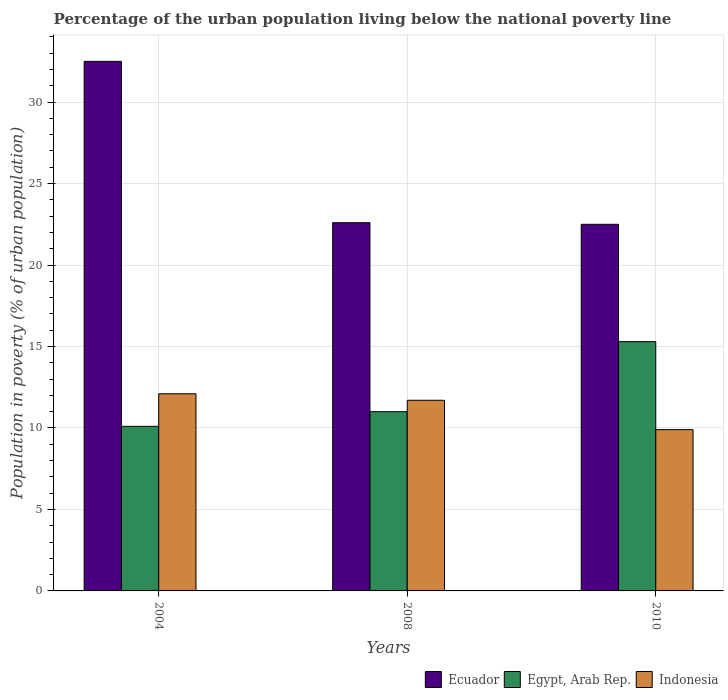Are the number of bars per tick equal to the number of legend labels?
Make the answer very short. Yes. How many bars are there on the 1st tick from the left?
Make the answer very short. 3. What is the label of the 2nd group of bars from the left?
Your response must be concise. 2008. In how many cases, is the number of bars for a given year not equal to the number of legend labels?
Make the answer very short. 0. What is the percentage of the urban population living below the national poverty line in Indonesia in 2010?
Offer a very short reply. 9.9. In which year was the percentage of the urban population living below the national poverty line in Indonesia maximum?
Offer a very short reply. 2004. What is the total percentage of the urban population living below the national poverty line in Ecuador in the graph?
Offer a terse response. 77.6. What is the difference between the percentage of the urban population living below the national poverty line in Indonesia in 2004 and that in 2010?
Provide a short and direct response. 2.2. What is the average percentage of the urban population living below the national poverty line in Indonesia per year?
Offer a terse response. 11.23. In the year 2004, what is the difference between the percentage of the urban population living below the national poverty line in Ecuador and percentage of the urban population living below the national poverty line in Indonesia?
Provide a succinct answer. 20.4. What is the ratio of the percentage of the urban population living below the national poverty line in Indonesia in 2004 to that in 2008?
Provide a succinct answer. 1.03. Is the percentage of the urban population living below the national poverty line in Ecuador in 2008 less than that in 2010?
Give a very brief answer. No. Is the difference between the percentage of the urban population living below the national poverty line in Ecuador in 2004 and 2008 greater than the difference between the percentage of the urban population living below the national poverty line in Indonesia in 2004 and 2008?
Your answer should be compact. Yes. What is the difference between the highest and the second highest percentage of the urban population living below the national poverty line in Indonesia?
Keep it short and to the point. 0.4. What is the difference between the highest and the lowest percentage of the urban population living below the national poverty line in Egypt, Arab Rep.?
Your response must be concise. 5.2. In how many years, is the percentage of the urban population living below the national poverty line in Indonesia greater than the average percentage of the urban population living below the national poverty line in Indonesia taken over all years?
Provide a succinct answer. 2. Is the sum of the percentage of the urban population living below the national poverty line in Ecuador in 2008 and 2010 greater than the maximum percentage of the urban population living below the national poverty line in Indonesia across all years?
Provide a succinct answer. Yes. What does the 2nd bar from the right in 2004 represents?
Your answer should be compact. Egypt, Arab Rep. How many bars are there?
Make the answer very short. 9. How many years are there in the graph?
Make the answer very short. 3. Where does the legend appear in the graph?
Keep it short and to the point. Bottom right. How many legend labels are there?
Provide a succinct answer. 3. What is the title of the graph?
Keep it short and to the point. Percentage of the urban population living below the national poverty line. What is the label or title of the Y-axis?
Provide a short and direct response. Population in poverty (% of urban population). What is the Population in poverty (% of urban population) of Ecuador in 2004?
Give a very brief answer. 32.5. What is the Population in poverty (% of urban population) of Egypt, Arab Rep. in 2004?
Give a very brief answer. 10.1. What is the Population in poverty (% of urban population) in Ecuador in 2008?
Offer a very short reply. 22.6. What is the Population in poverty (% of urban population) in Egypt, Arab Rep. in 2008?
Provide a succinct answer. 11. What is the Population in poverty (% of urban population) of Ecuador in 2010?
Ensure brevity in your answer.  22.5. What is the Population in poverty (% of urban population) in Egypt, Arab Rep. in 2010?
Provide a succinct answer. 15.3. Across all years, what is the maximum Population in poverty (% of urban population) in Ecuador?
Offer a terse response. 32.5. Across all years, what is the maximum Population in poverty (% of urban population) of Indonesia?
Offer a terse response. 12.1. Across all years, what is the minimum Population in poverty (% of urban population) of Ecuador?
Provide a short and direct response. 22.5. Across all years, what is the minimum Population in poverty (% of urban population) of Egypt, Arab Rep.?
Offer a very short reply. 10.1. Across all years, what is the minimum Population in poverty (% of urban population) in Indonesia?
Make the answer very short. 9.9. What is the total Population in poverty (% of urban population) of Ecuador in the graph?
Keep it short and to the point. 77.6. What is the total Population in poverty (% of urban population) in Egypt, Arab Rep. in the graph?
Provide a short and direct response. 36.4. What is the total Population in poverty (% of urban population) in Indonesia in the graph?
Provide a short and direct response. 33.7. What is the difference between the Population in poverty (% of urban population) in Indonesia in 2004 and that in 2008?
Provide a short and direct response. 0.4. What is the difference between the Population in poverty (% of urban population) in Egypt, Arab Rep. in 2004 and that in 2010?
Make the answer very short. -5.2. What is the difference between the Population in poverty (% of urban population) in Indonesia in 2004 and that in 2010?
Your response must be concise. 2.2. What is the difference between the Population in poverty (% of urban population) in Egypt, Arab Rep. in 2008 and that in 2010?
Offer a very short reply. -4.3. What is the difference between the Population in poverty (% of urban population) in Indonesia in 2008 and that in 2010?
Give a very brief answer. 1.8. What is the difference between the Population in poverty (% of urban population) of Ecuador in 2004 and the Population in poverty (% of urban population) of Indonesia in 2008?
Offer a very short reply. 20.8. What is the difference between the Population in poverty (% of urban population) of Ecuador in 2004 and the Population in poverty (% of urban population) of Egypt, Arab Rep. in 2010?
Your response must be concise. 17.2. What is the difference between the Population in poverty (% of urban population) in Ecuador in 2004 and the Population in poverty (% of urban population) in Indonesia in 2010?
Offer a very short reply. 22.6. What is the difference between the Population in poverty (% of urban population) in Ecuador in 2008 and the Population in poverty (% of urban population) in Indonesia in 2010?
Keep it short and to the point. 12.7. What is the difference between the Population in poverty (% of urban population) of Egypt, Arab Rep. in 2008 and the Population in poverty (% of urban population) of Indonesia in 2010?
Offer a terse response. 1.1. What is the average Population in poverty (% of urban population) in Ecuador per year?
Your answer should be compact. 25.87. What is the average Population in poverty (% of urban population) in Egypt, Arab Rep. per year?
Provide a short and direct response. 12.13. What is the average Population in poverty (% of urban population) in Indonesia per year?
Keep it short and to the point. 11.23. In the year 2004, what is the difference between the Population in poverty (% of urban population) of Ecuador and Population in poverty (% of urban population) of Egypt, Arab Rep.?
Keep it short and to the point. 22.4. In the year 2004, what is the difference between the Population in poverty (% of urban population) of Ecuador and Population in poverty (% of urban population) of Indonesia?
Keep it short and to the point. 20.4. In the year 2004, what is the difference between the Population in poverty (% of urban population) in Egypt, Arab Rep. and Population in poverty (% of urban population) in Indonesia?
Ensure brevity in your answer.  -2. In the year 2008, what is the difference between the Population in poverty (% of urban population) in Ecuador and Population in poverty (% of urban population) in Egypt, Arab Rep.?
Provide a short and direct response. 11.6. In the year 2008, what is the difference between the Population in poverty (% of urban population) of Ecuador and Population in poverty (% of urban population) of Indonesia?
Provide a succinct answer. 10.9. In the year 2008, what is the difference between the Population in poverty (% of urban population) of Egypt, Arab Rep. and Population in poverty (% of urban population) of Indonesia?
Provide a succinct answer. -0.7. In the year 2010, what is the difference between the Population in poverty (% of urban population) of Ecuador and Population in poverty (% of urban population) of Indonesia?
Offer a terse response. 12.6. What is the ratio of the Population in poverty (% of urban population) in Ecuador in 2004 to that in 2008?
Ensure brevity in your answer.  1.44. What is the ratio of the Population in poverty (% of urban population) of Egypt, Arab Rep. in 2004 to that in 2008?
Provide a succinct answer. 0.92. What is the ratio of the Population in poverty (% of urban population) of Indonesia in 2004 to that in 2008?
Your response must be concise. 1.03. What is the ratio of the Population in poverty (% of urban population) in Ecuador in 2004 to that in 2010?
Your answer should be very brief. 1.44. What is the ratio of the Population in poverty (% of urban population) of Egypt, Arab Rep. in 2004 to that in 2010?
Make the answer very short. 0.66. What is the ratio of the Population in poverty (% of urban population) in Indonesia in 2004 to that in 2010?
Ensure brevity in your answer.  1.22. What is the ratio of the Population in poverty (% of urban population) of Ecuador in 2008 to that in 2010?
Provide a short and direct response. 1. What is the ratio of the Population in poverty (% of urban population) in Egypt, Arab Rep. in 2008 to that in 2010?
Make the answer very short. 0.72. What is the ratio of the Population in poverty (% of urban population) in Indonesia in 2008 to that in 2010?
Ensure brevity in your answer.  1.18. What is the difference between the highest and the lowest Population in poverty (% of urban population) in Egypt, Arab Rep.?
Keep it short and to the point. 5.2. 